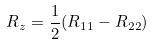Convert formula to latex. <formula><loc_0><loc_0><loc_500><loc_500>R _ { z } = \frac { 1 } { 2 } ( R _ { 1 1 } - R _ { 2 2 } )</formula> 